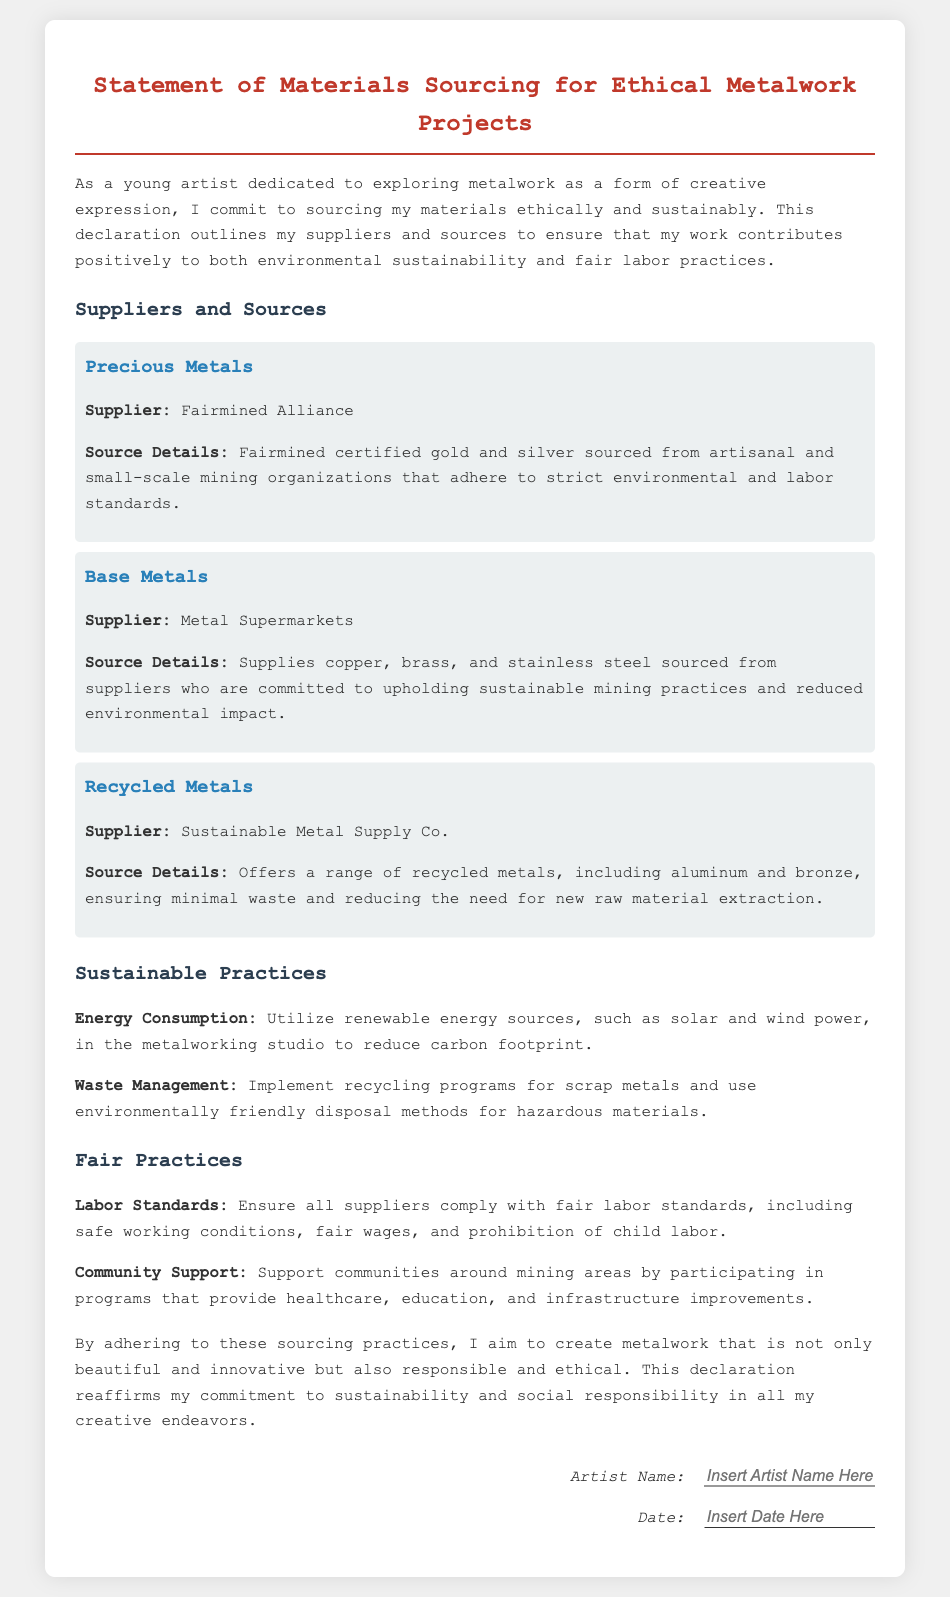What is the title of the document? The title is found at the top of the document, indicating the main subject matter.
Answer: Statement of Materials Sourcing for Ethical Metalwork Projects Who is the supplier for recycled metals? The document lists suppliers under specific categories, where the section for recycled metals identifies the supplier's name.
Answer: Sustainable Metal Supply Co What type of metals does Fairmined Alliance supply? The document specifies which metals are offered by each supplier, focusing on those that meet the ethical sourcing criteria.
Answer: Gold and silver How does the document propose to manage waste? The document includes a section explaining practices for handling waste, providing details on specific strategies to reduce environmental impact.
Answer: Implement recycling programs What energy sources are suggested for the metalworking studio? The document mentions renewable energy sources under sustainable practices, highlighting the types of energy proposed for use.
Answer: Solar and wind power What labor standard is emphasized in the declaration? The document discusses fair labor standards, identifying specific practices that ensure ethical treatment of workers.
Answer: Fair wages Which supplier offers base metals? The document categorizes suppliers and specifies which types of metals are provided, particularly focusing on base metals.
Answer: Metal Supermarkets What commitment does the artist make regarding their work? The document outlines the overarching commitment of the artist to ethical practices in their craft, summarizing their intent.
Answer: Create responsible and ethical metalwork 